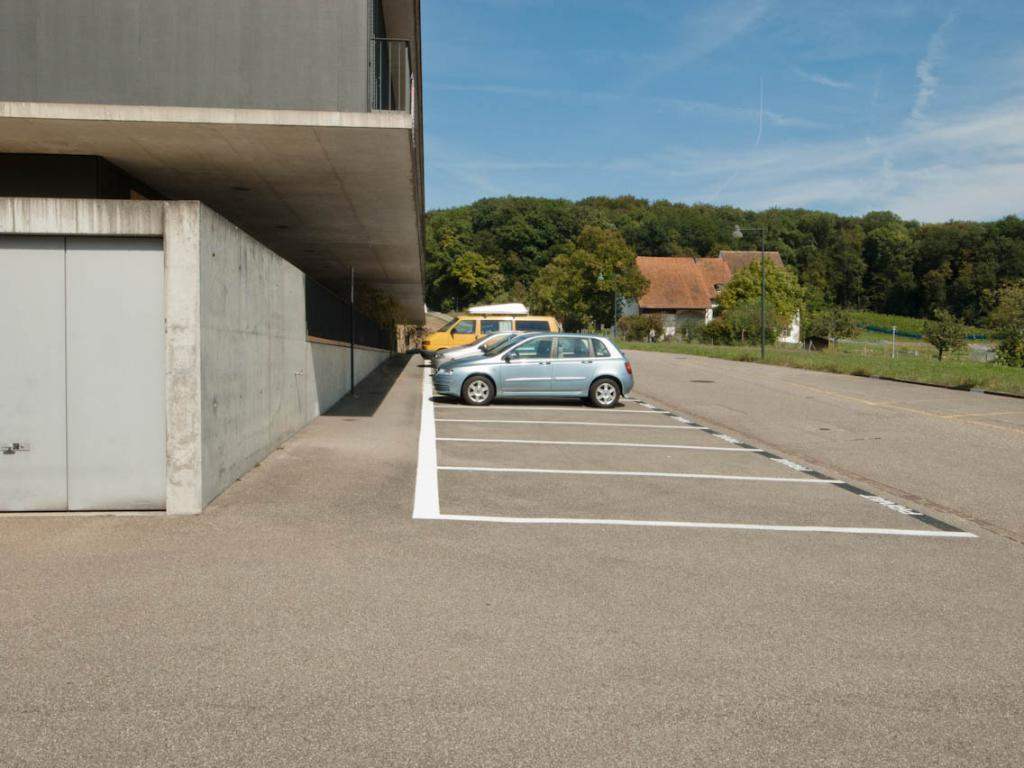What type of structures can be seen in the image? There are buildings in the image. What vehicles are parked in the image? There are cars parked in the image. What type of vegetation is visible in the image? There are trees visible in the image. What type of ground cover is present in the image? There is grass on the ground in the image. How would you describe the sky in the image? The sky is blue and cloudy in the image. What color is the lock on the throat of the person in the image? There is no person or lock present in the image. How many toes are visible on the person in the image? There is no person present in the image, so no toes can be seen. 